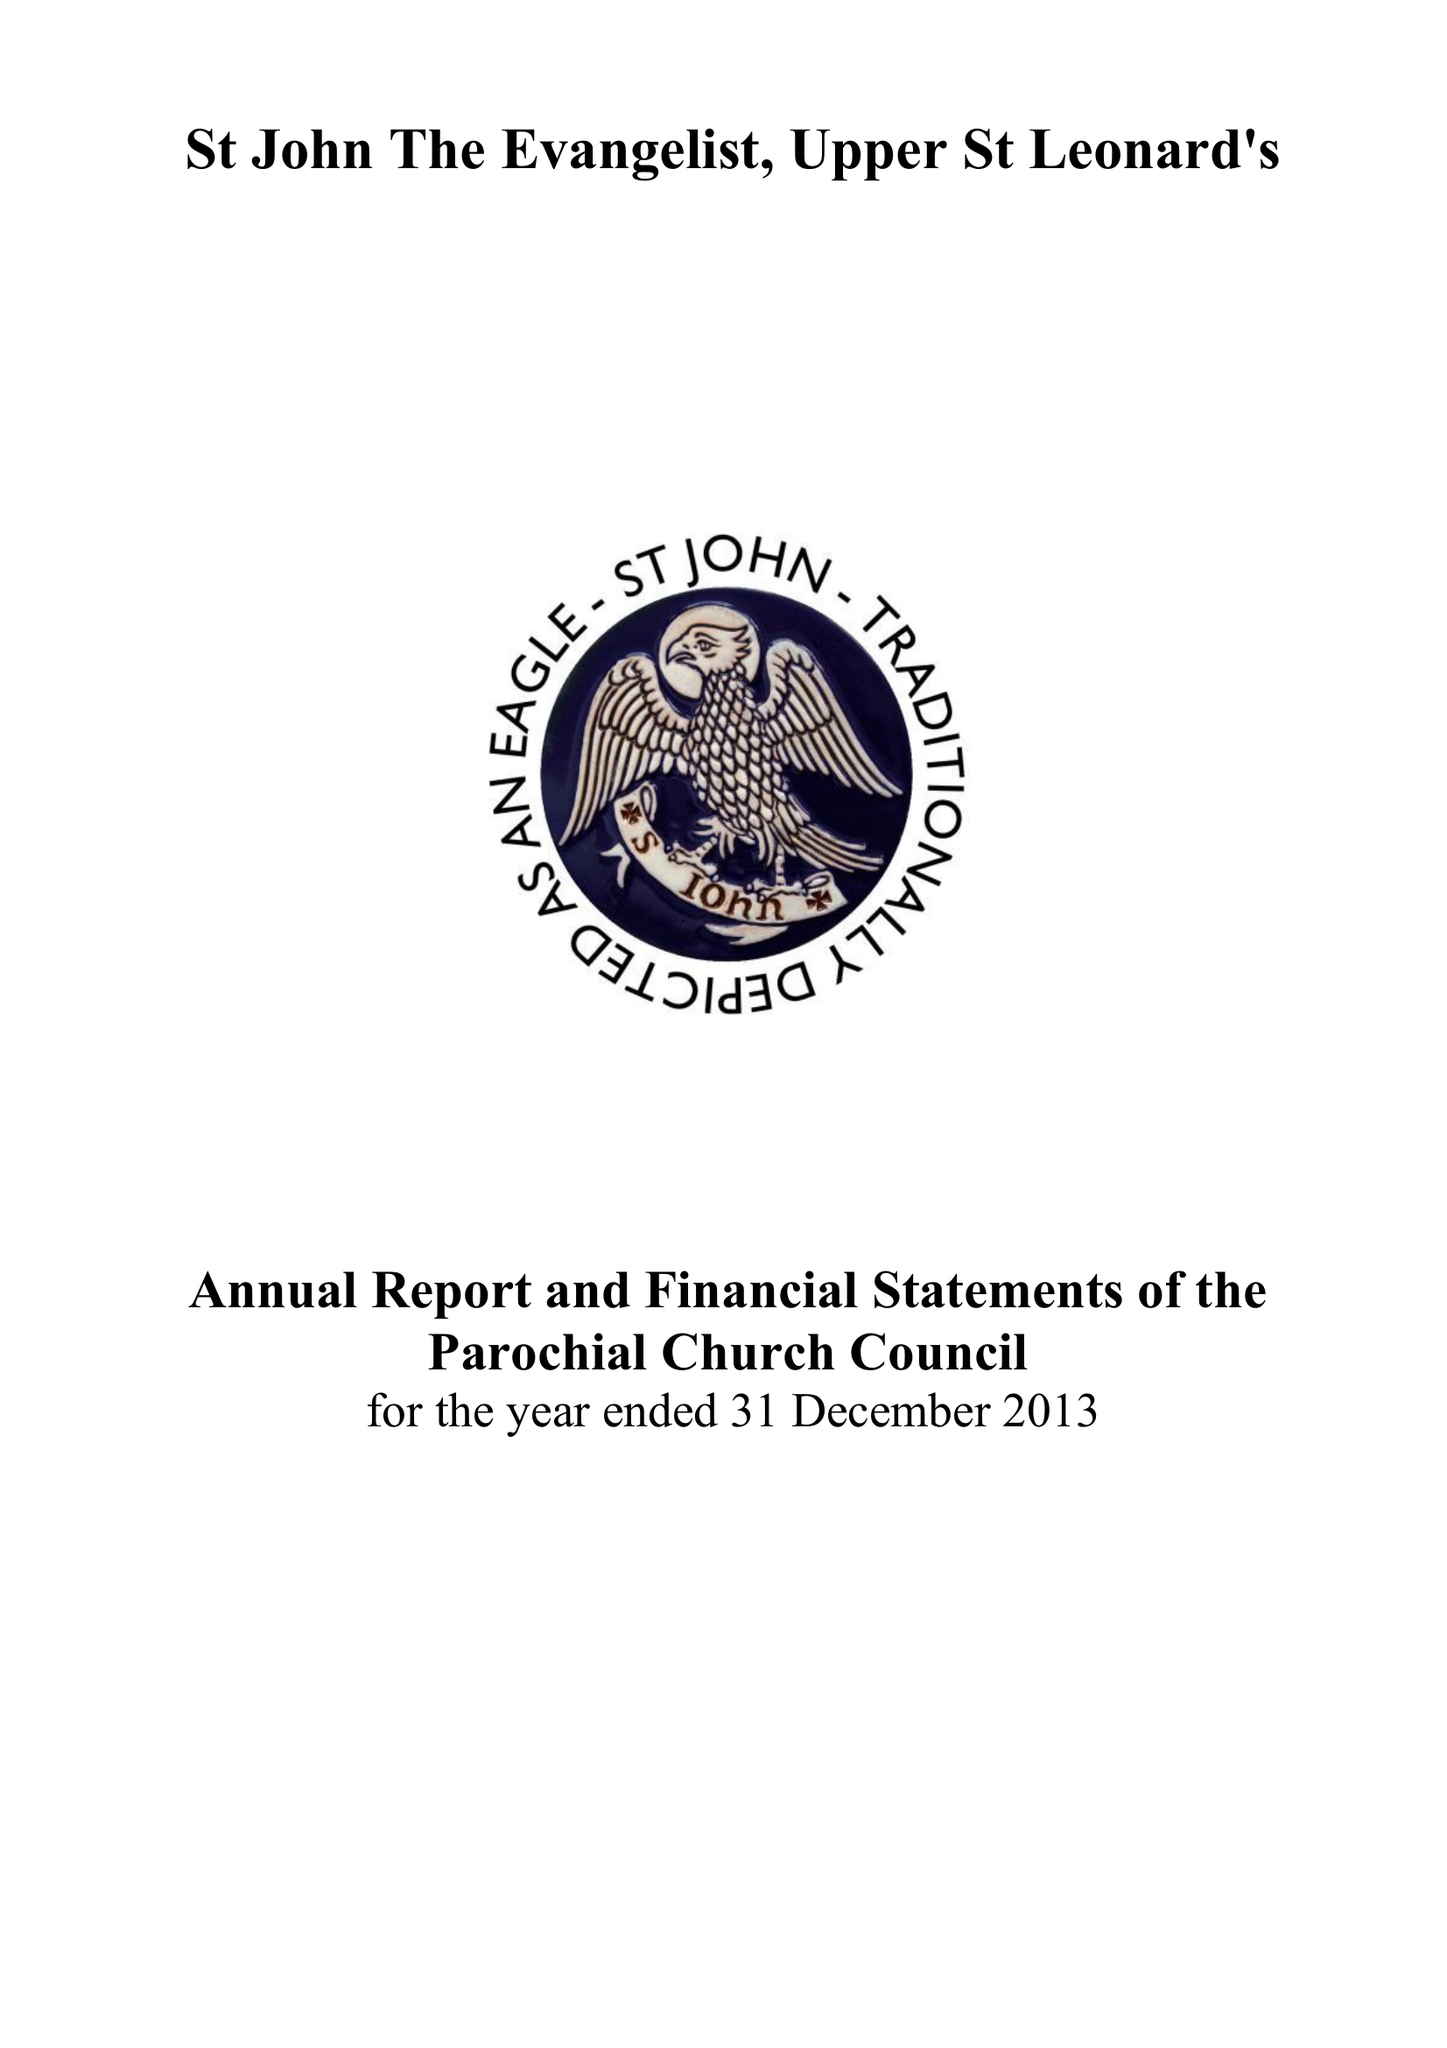What is the value for the address__street_line?
Answer the question using a single word or phrase. PEVENSEY ROAD 